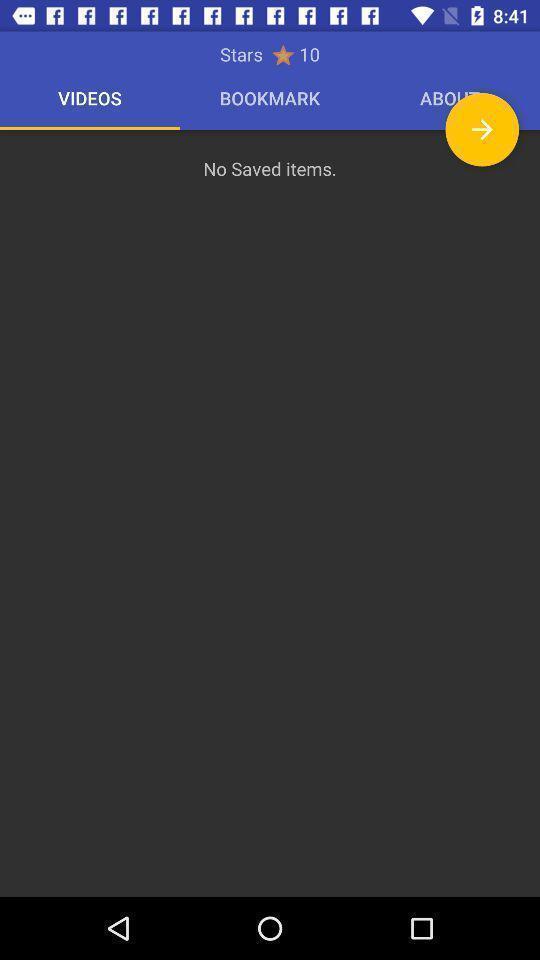Describe the content in this image. Screen page displaying status with various options. 